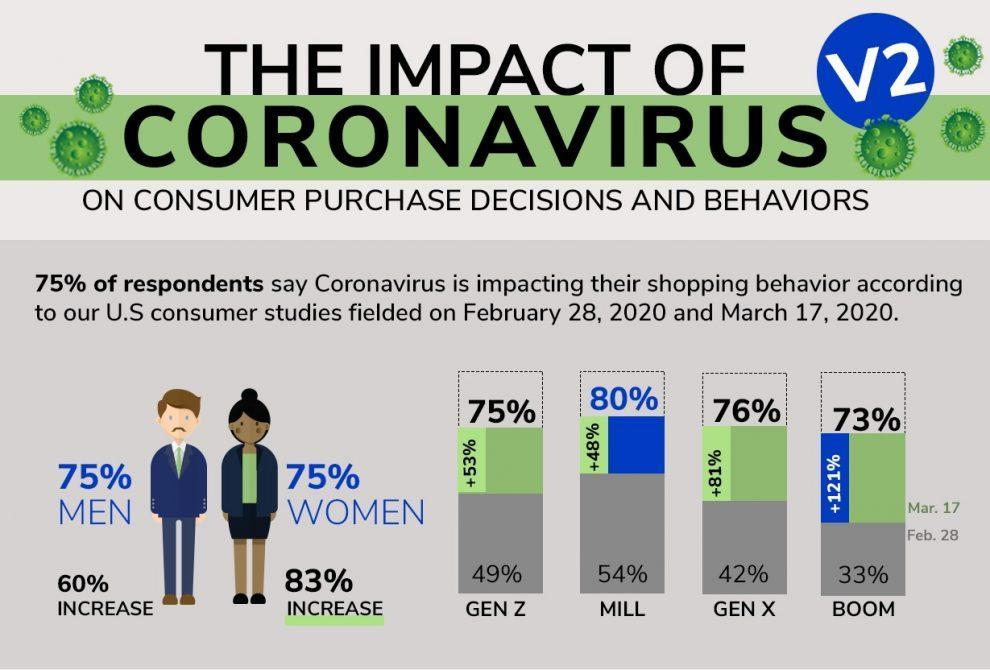What percentage of respondents disagree that coronavirus affects their shopping behavior?
Answer the question with a short phrase. 25% 